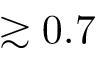<formula> <loc_0><loc_0><loc_500><loc_500>\gtrsim 0 . 7</formula> 